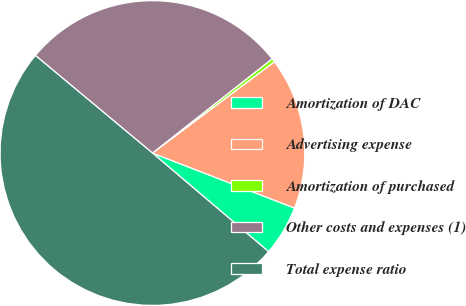Convert chart to OTSL. <chart><loc_0><loc_0><loc_500><loc_500><pie_chart><fcel>Amortization of DAC<fcel>Advertising expense<fcel>Amortization of purchased<fcel>Other costs and expenses (1)<fcel>Total expense ratio<nl><fcel>5.33%<fcel>16.1%<fcel>0.39%<fcel>28.32%<fcel>49.85%<nl></chart> 